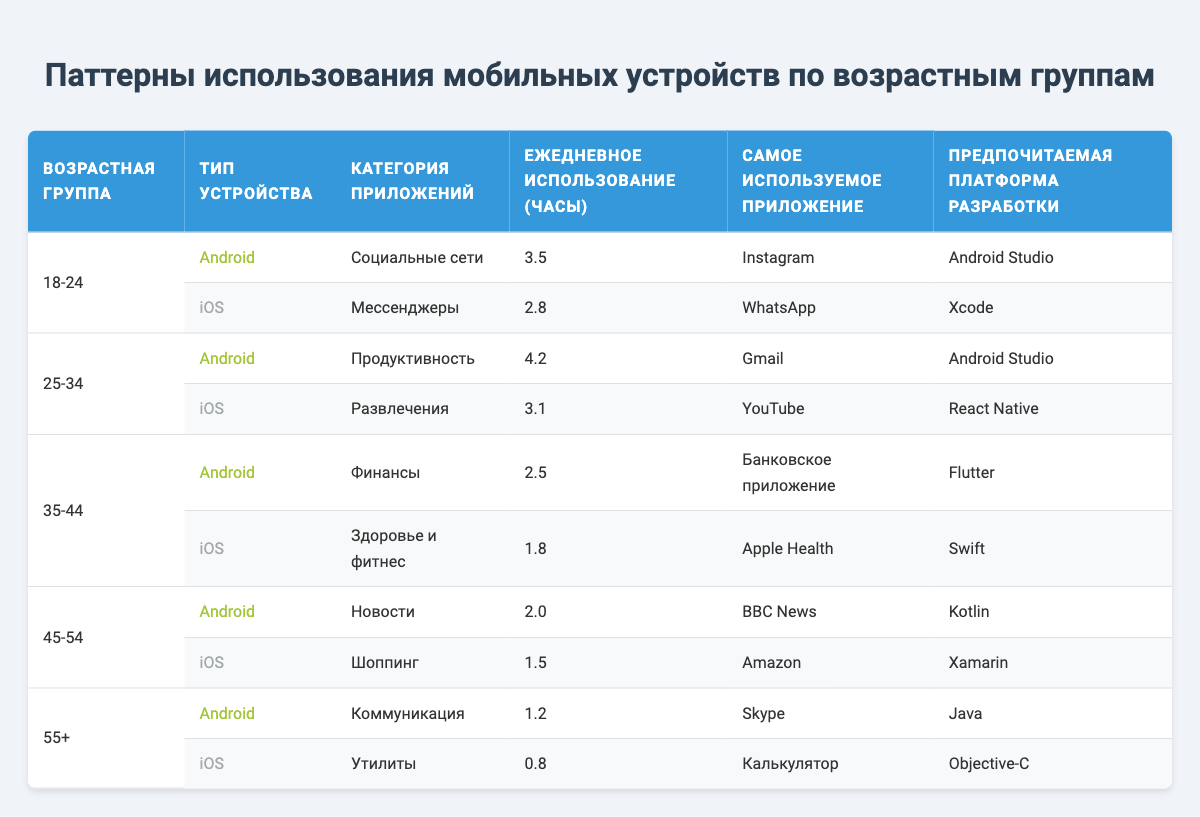What is the most used app among people aged 18-24 using Android devices? According to the table, the most used app by people aged 18-24 using Android devices is Instagram.
Answer: Instagram What is the daily usage in hours for the iOS app category titled "Health & Fitness"? The table shows that for the age group 35-44, the daily usage for the iOS app category "Health & Fitness" is 1.8 hours.
Answer: 1.8 Which age group has the highest daily usage hours for Android devices? The age group 25-34 has the highest daily usage hours for Android devices, with a total of 4.2 hours as listed under the app category "Productivity."
Answer: 25-34 Is the most used app in the "Finance" category an Android or iOS application? The table indicates that the most used app in the "Finance" category is a banking application, which falls under the Android device type.
Answer: Android What is the average daily usage in hours across all age groups for iOS devices? To calculate this, grab the daily usage hours for iOS apps: 2.8 (18-24) + 3.1 (25-34) + 1.8 (35-44) + 1.5 (45-54) + 0.8 (55+) = 9.0 hours. There are 5 entries, so the average is 9.0 / 5 = 1.8 hours.
Answer: 1.8 Do users aged 55+ spend more time on Android or iOS devices? Users aged 55+ spend more time on Android devices (1.2 hours) compared to iOS devices (0.8 hours) based on the data.
Answer: Android Which age group shows a higher preference for the "Social Media" app category? The table indicates that the 18-24 age group uses the "Social Media" category, specifically using Instagram for 3.5 hours. There are no other age groups listed in this category, making the preference clear.
Answer: 18-24 How many hours do people aged 45-54 spend on the "Shopping" app category on iOS devices? The table shows that the daily usage for the "Shopping" app category (iOS) among the 45-54 age group is 1.5 hours.
Answer: 1.5 What is the most commonly preferred development platform for the 35-44 age group users? The preferred development platform for users in the 35-44 age group is divided between Android and iOS, with Flutter for Android and Swift for iOS. However, "Flutter" for Android usage is mentioned first, indicating it as a lead platform.
Answer: Flutter 